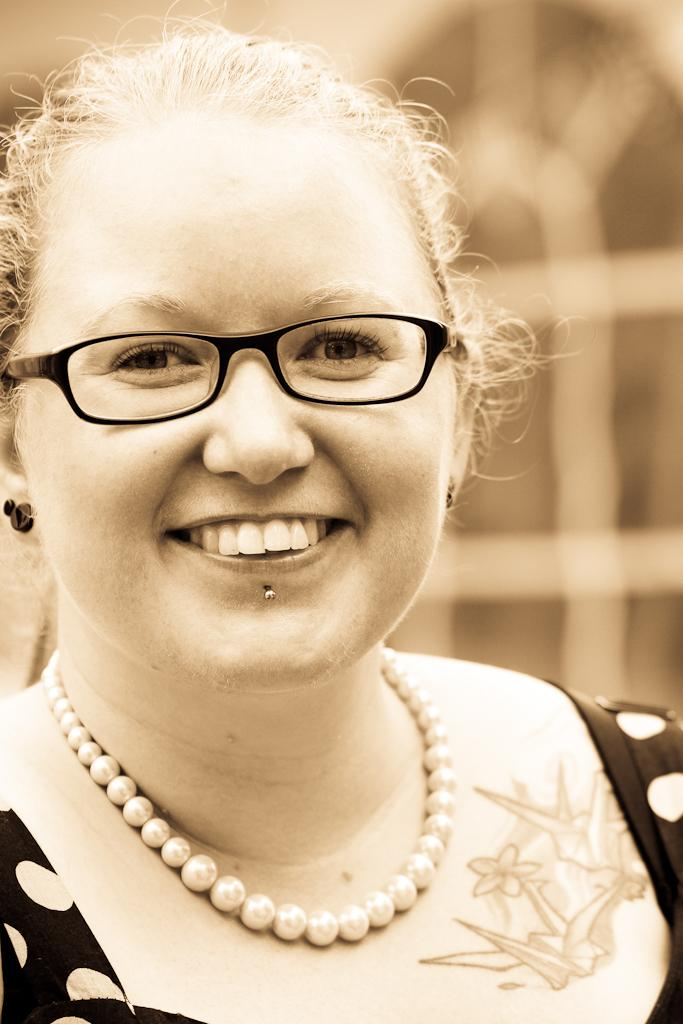What is the color scheme of the image? The image is black and white. Who is the main subject in the image? There is a woman in the image. What accessories is the woman wearing? The woman is wearing a chain and spectacles. What is the woman's facial expression in the image? The woman is smiling. What is the woman doing in the image? The woman is giving a pose for the picture. How is the background of the image depicted? The background of the image is blurred. What type of sticks can be seen in the woman's hand in the image? There are no sticks present in the woman's hand or in the image. What kind of operation is the woman performing in the image? There is no operation being performed in the image; the woman is simply posing for a picture. 